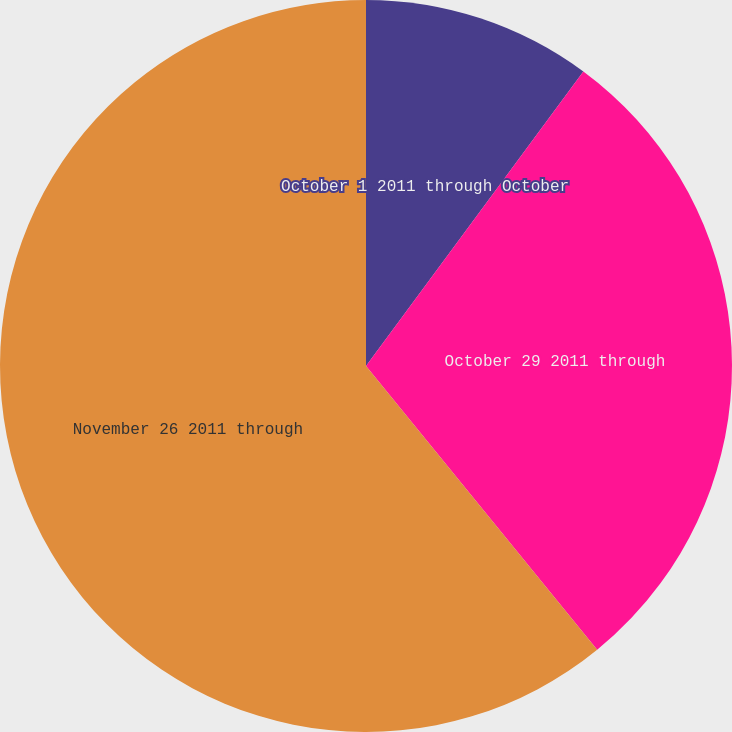Convert chart. <chart><loc_0><loc_0><loc_500><loc_500><pie_chart><fcel>October 1 2011 through October<fcel>October 29 2011 through<fcel>November 26 2011 through<nl><fcel>10.12%<fcel>29.0%<fcel>60.88%<nl></chart> 